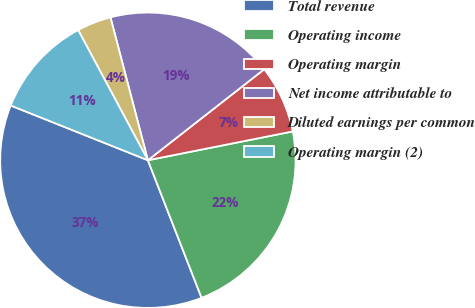Convert chart. <chart><loc_0><loc_0><loc_500><loc_500><pie_chart><fcel>Total revenue<fcel>Operating income<fcel>Operating margin<fcel>Net income attributable to<fcel>Diluted earnings per common<fcel>Operating margin (2)<nl><fcel>36.96%<fcel>22.2%<fcel>7.44%<fcel>18.51%<fcel>3.75%<fcel>11.13%<nl></chart> 